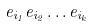Convert formula to latex. <formula><loc_0><loc_0><loc_500><loc_500>e _ { i _ { 1 } } e _ { i _ { 2 } } \dots e _ { i _ { k } }</formula> 